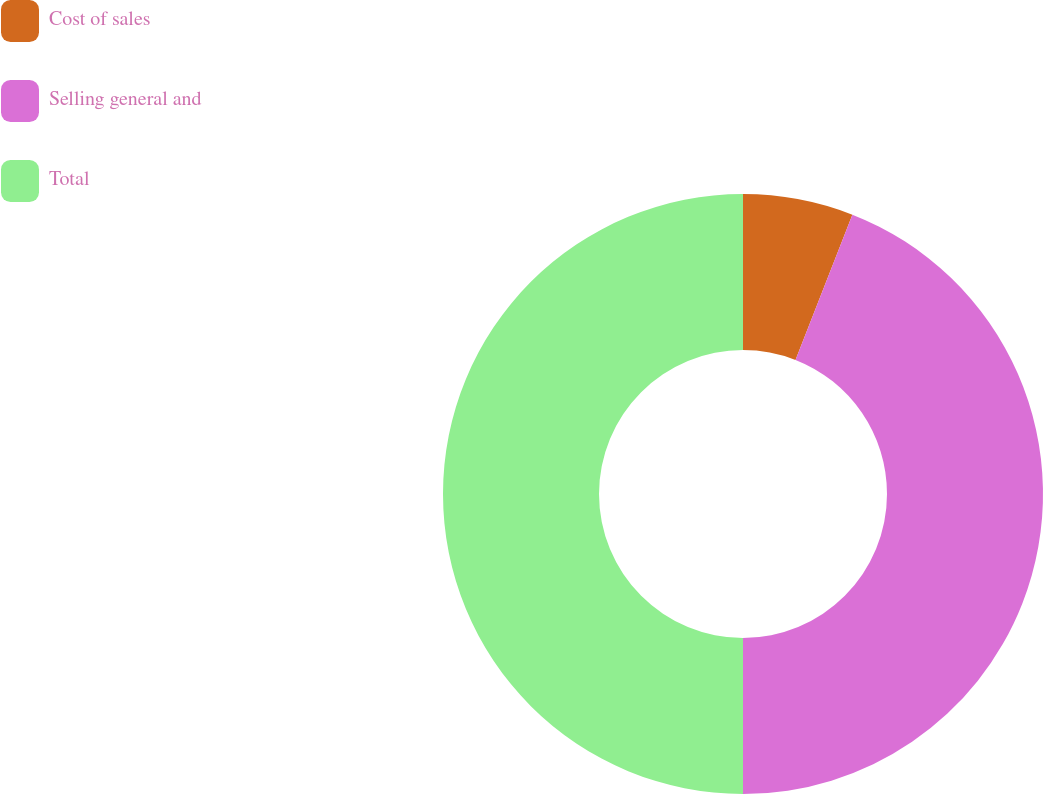<chart> <loc_0><loc_0><loc_500><loc_500><pie_chart><fcel>Cost of sales<fcel>Selling general and<fcel>Total<nl><fcel>5.94%<fcel>44.06%<fcel>50.0%<nl></chart> 